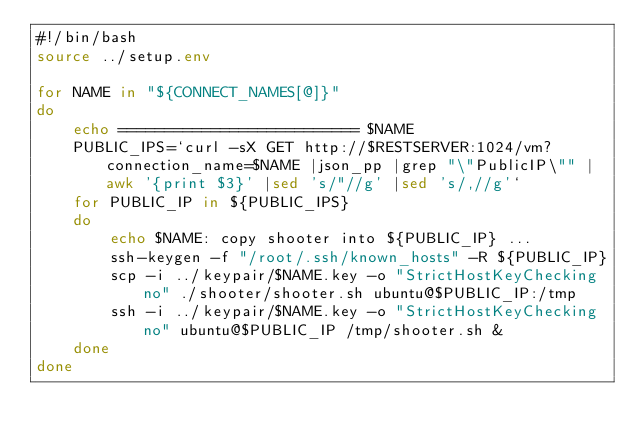<code> <loc_0><loc_0><loc_500><loc_500><_Bash_>#!/bin/bash
source ../setup.env

for NAME in "${CONNECT_NAMES[@]}"
do
	echo ========================== $NAME
	PUBLIC_IPS=`curl -sX GET http://$RESTSERVER:1024/vm?connection_name=$NAME |json_pp |grep "\"PublicIP\"" |awk '{print $3}' |sed 's/"//g' |sed 's/,//g'`
	for PUBLIC_IP in ${PUBLIC_IPS}
	do
		echo $NAME: copy shooter into ${PUBLIC_IP} ...
		ssh-keygen -f "/root/.ssh/known_hosts" -R ${PUBLIC_IP}
		scp -i ../keypair/$NAME.key -o "StrictHostKeyChecking no" ./shooter/shooter.sh ubuntu@$PUBLIC_IP:/tmp
		ssh -i ../keypair/$NAME.key -o "StrictHostKeyChecking no" ubuntu@$PUBLIC_IP /tmp/shooter.sh &
	done
done
</code> 